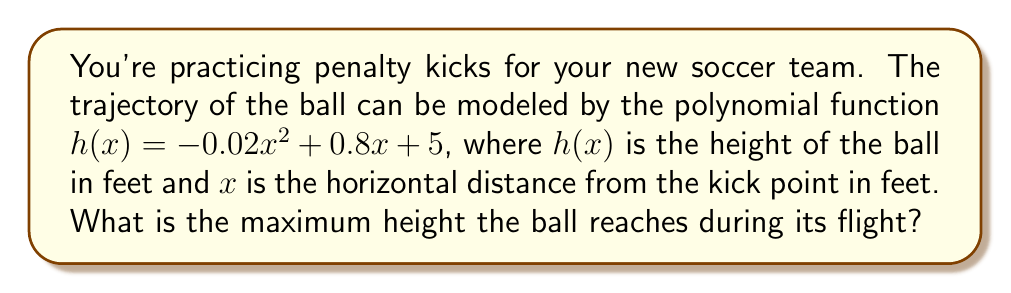Show me your answer to this math problem. To find the maximum height of the ball, we need to follow these steps:

1) The function $h(x) = -0.02x^2 + 0.8x + 5$ is a quadratic function, which forms a parabola when graphed.

2) For a parabola that opens downward (negative coefficient of $x^2$), the vertex represents the highest point.

3) To find the x-coordinate of the vertex, we use the formula: $x = -\frac{b}{2a}$, where $a$ and $b$ are the coefficients of $x^2$ and $x$ respectively.

4) In this case, $a = -0.02$ and $b = 0.8$:

   $x = -\frac{0.8}{2(-0.02)} = -\frac{0.8}{-0.04} = 20$

5) Now that we know the x-coordinate of the vertex, we can find the maximum height by plugging this x-value back into the original function:

   $h(20) = -0.02(20)^2 + 0.8(20) + 5$
   $= -0.02(400) + 16 + 5$
   $= -8 + 16 + 5$
   $= 13$

Therefore, the maximum height the ball reaches is 13 feet.
Answer: 13 feet 